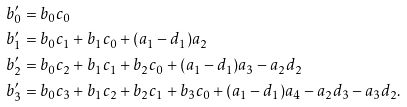<formula> <loc_0><loc_0><loc_500><loc_500>b ^ { \prime } _ { 0 } & = b _ { 0 } c _ { 0 } \\ b ^ { \prime } _ { 1 } & = b _ { 0 } c _ { 1 } + b _ { 1 } c _ { 0 } + ( a _ { 1 } - d _ { 1 } ) a _ { 2 } \\ b ^ { \prime } _ { 2 } & = b _ { 0 } c _ { 2 } + b _ { 1 } c _ { 1 } + b _ { 2 } c _ { 0 } + ( a _ { 1 } - d _ { 1 } ) a _ { 3 } - a _ { 2 } d _ { 2 } \\ b ^ { \prime } _ { 3 } & = b _ { 0 } c _ { 3 } + b _ { 1 } c _ { 2 } + b _ { 2 } c _ { 1 } + b _ { 3 } c _ { 0 } + ( a _ { 1 } - d _ { 1 } ) a _ { 4 } - a _ { 2 } d _ { 3 } - a _ { 3 } d _ { 2 } . \\</formula> 